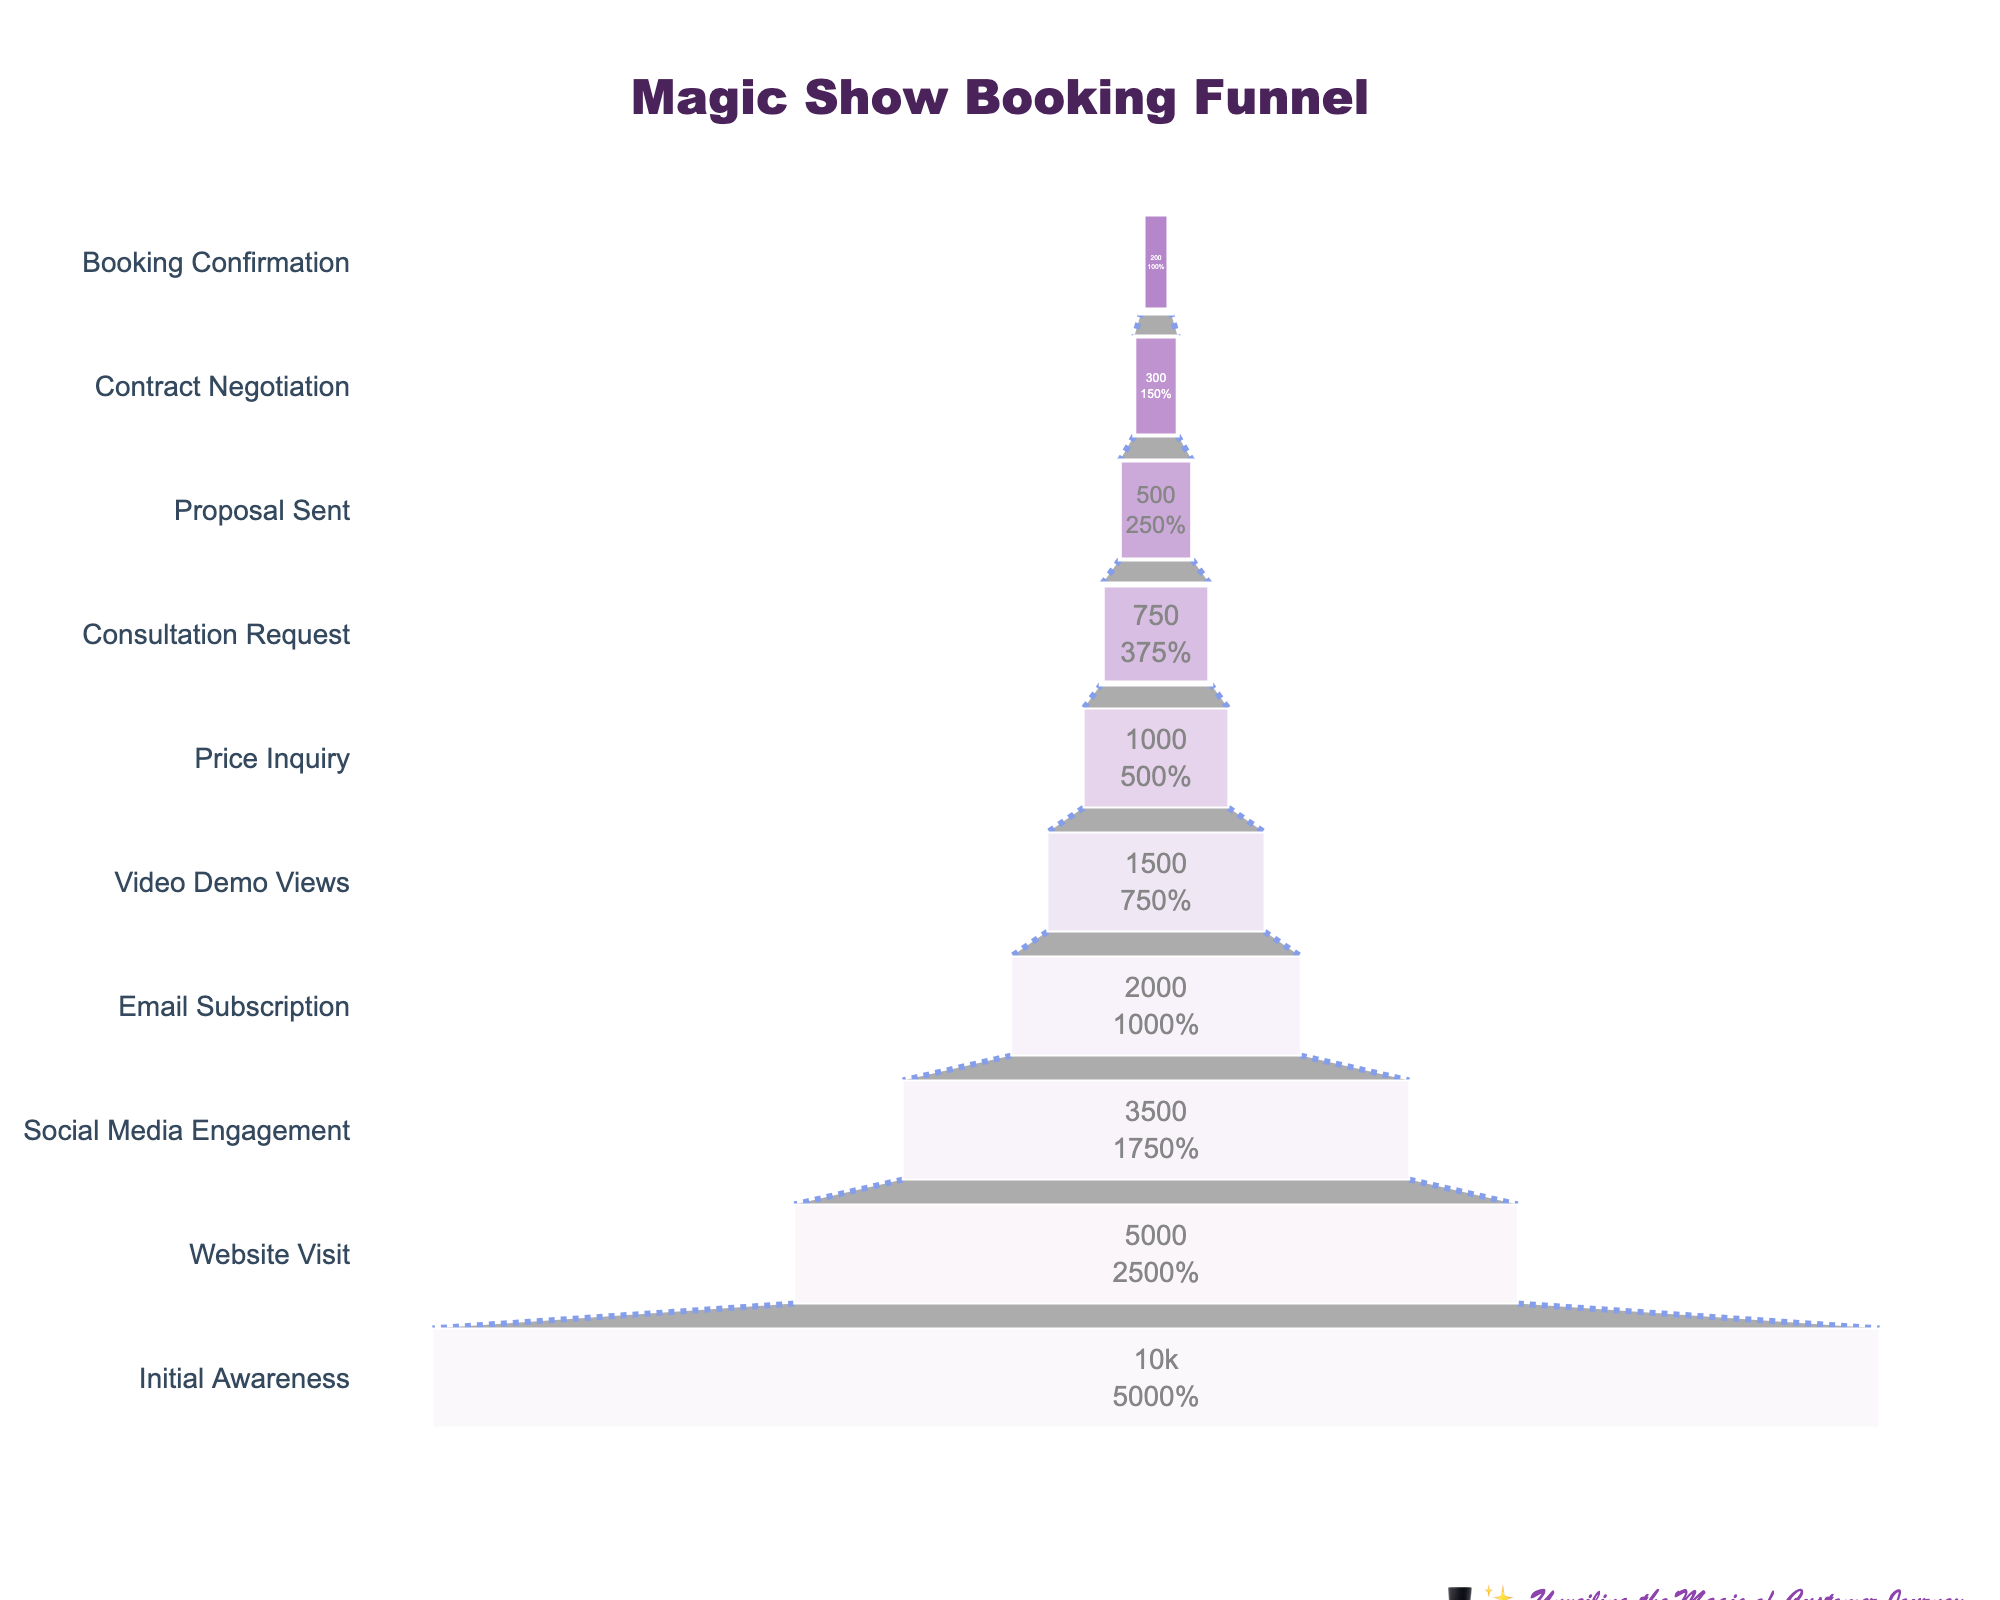Which stage has the highest number of people? According to the funnel chart data, the "Initial Awareness" stage has the highest number of people, which is 10,000.
Answer: Initial Awareness How many stages are there in the funnel? The funnel chart shows a total of 10 stages, from "Initial Awareness" to "Booking Confirmation."
Answer: 10 What is the difference in the number of people between the "Website Visit" and "Email Subscription" stages? The "Website Visit" stage has 5,000 people, and the "Email Subscription" stage has 2,000 people. The difference is 5,000 - 2,000 = 3,000.
Answer: 3,000 Which stage has the lowest number of people? The "Booking Confirmation" stage has the lowest number of people, which is 200.
Answer: Booking Confirmation What proportion of people advance from "Initial Awareness" to "Website Visit"? To calculate the proportion, divide the number of people in the "Website Visit" stage by the number of people in the "Initial Awareness" stage. This is 5,000 / 10,000 = 0.5 or 50%.
Answer: 50% Is the number of people who engage on social media greater than those viewing the video demo? The "Social Media Engagement" stage has 3,500 people, whereas the "Video Demo Views" stage has 1,500 people. So yes, the number of people engaging on social media is greater than those viewing the video demo.
Answer: Yes What is the combined number of people for the stages "Proposal Sent" and "Contract Negotiation"? Adding the number of people in the "Proposal Sent" stage (500) and the "Contract Negotiation" stage (300), we get 500 + 300 = 800.
Answer: 800 What percentage of the initial audience ends up booking a magic show? To find the percentage, divide the number of people in the "Booking Confirmation" stage by the number of people in the "Initial Awareness" stage and multiply by 100. This is (200 / 10,000) * 100 = 2%.
Answer: 2% Which two consecutive stages have the largest drop-off in the number of people? The largest drop-off occurs between the "Initial Awareness" stage (10,000) and the "Website Visit" stage (5,000), with a drop of 10,000 - 5,000 = 5,000 people.
Answer: Initial Awareness to Website Visit How many fewer people are in the "Consultation Request" stage compared to the "Price Inquiry" stage? The "Consultation Request" stage has 750 people, and the "Price Inquiry" stage has 1,000 people. The difference is 1,000 - 750 = 250.
Answer: 250 